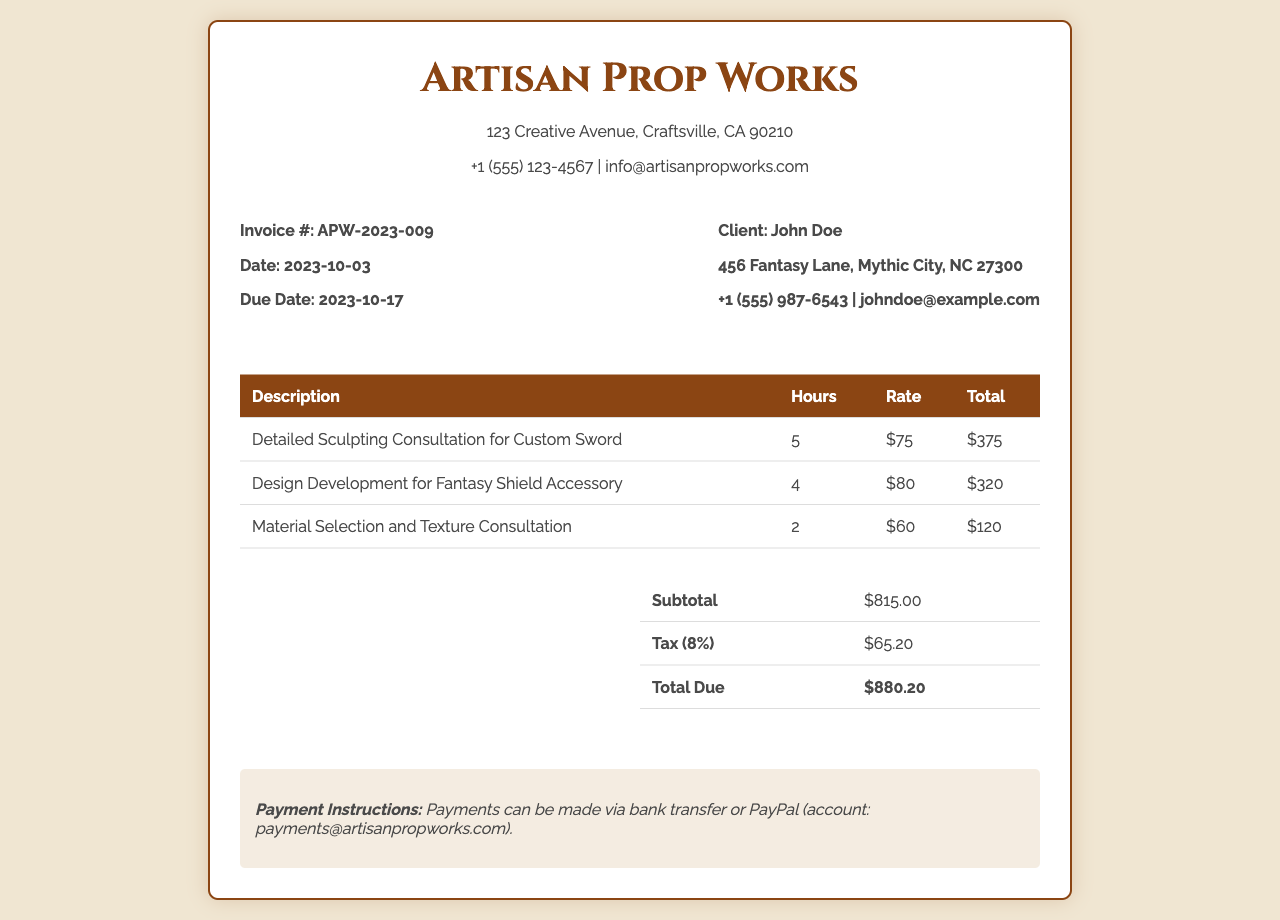What is the invoice number? The invoice number is listed prominently in the document as a unique identifier, which is APW-2023-009.
Answer: APW-2023-009 What is the total due amount? The total due amount is computed from the subtotal and tax, specifically shown as $880.20 in the summary section.
Answer: $880.20 Who is the client? The client's name is mentioned in the client info section, identifying the individual the services were rendered for as John Doe.
Answer: John Doe What date is the invoice issued? The date the invoice is issued can be found in the invoice details, specified as 2023-10-03.
Answer: 2023-10-03 How many hours were billed for the Detailed Sculpting Consultation? The number of hours for that specific service is listed in the associated row as 5 hours.
Answer: 5 What percentage is the tax? The tax percentage applied to the subtotal is clearly stated in the summary as 8%.
Answer: 8% What is the total for the Material Selection and Texture Consultation? The total charge for this consultation service is outlined in the table as $120.
Answer: $120 What is the payment method mentioned? The invoice outlines payment instructions, specifying PayPal as one of the methods, with an account for payment details provided.
Answer: PayPal 